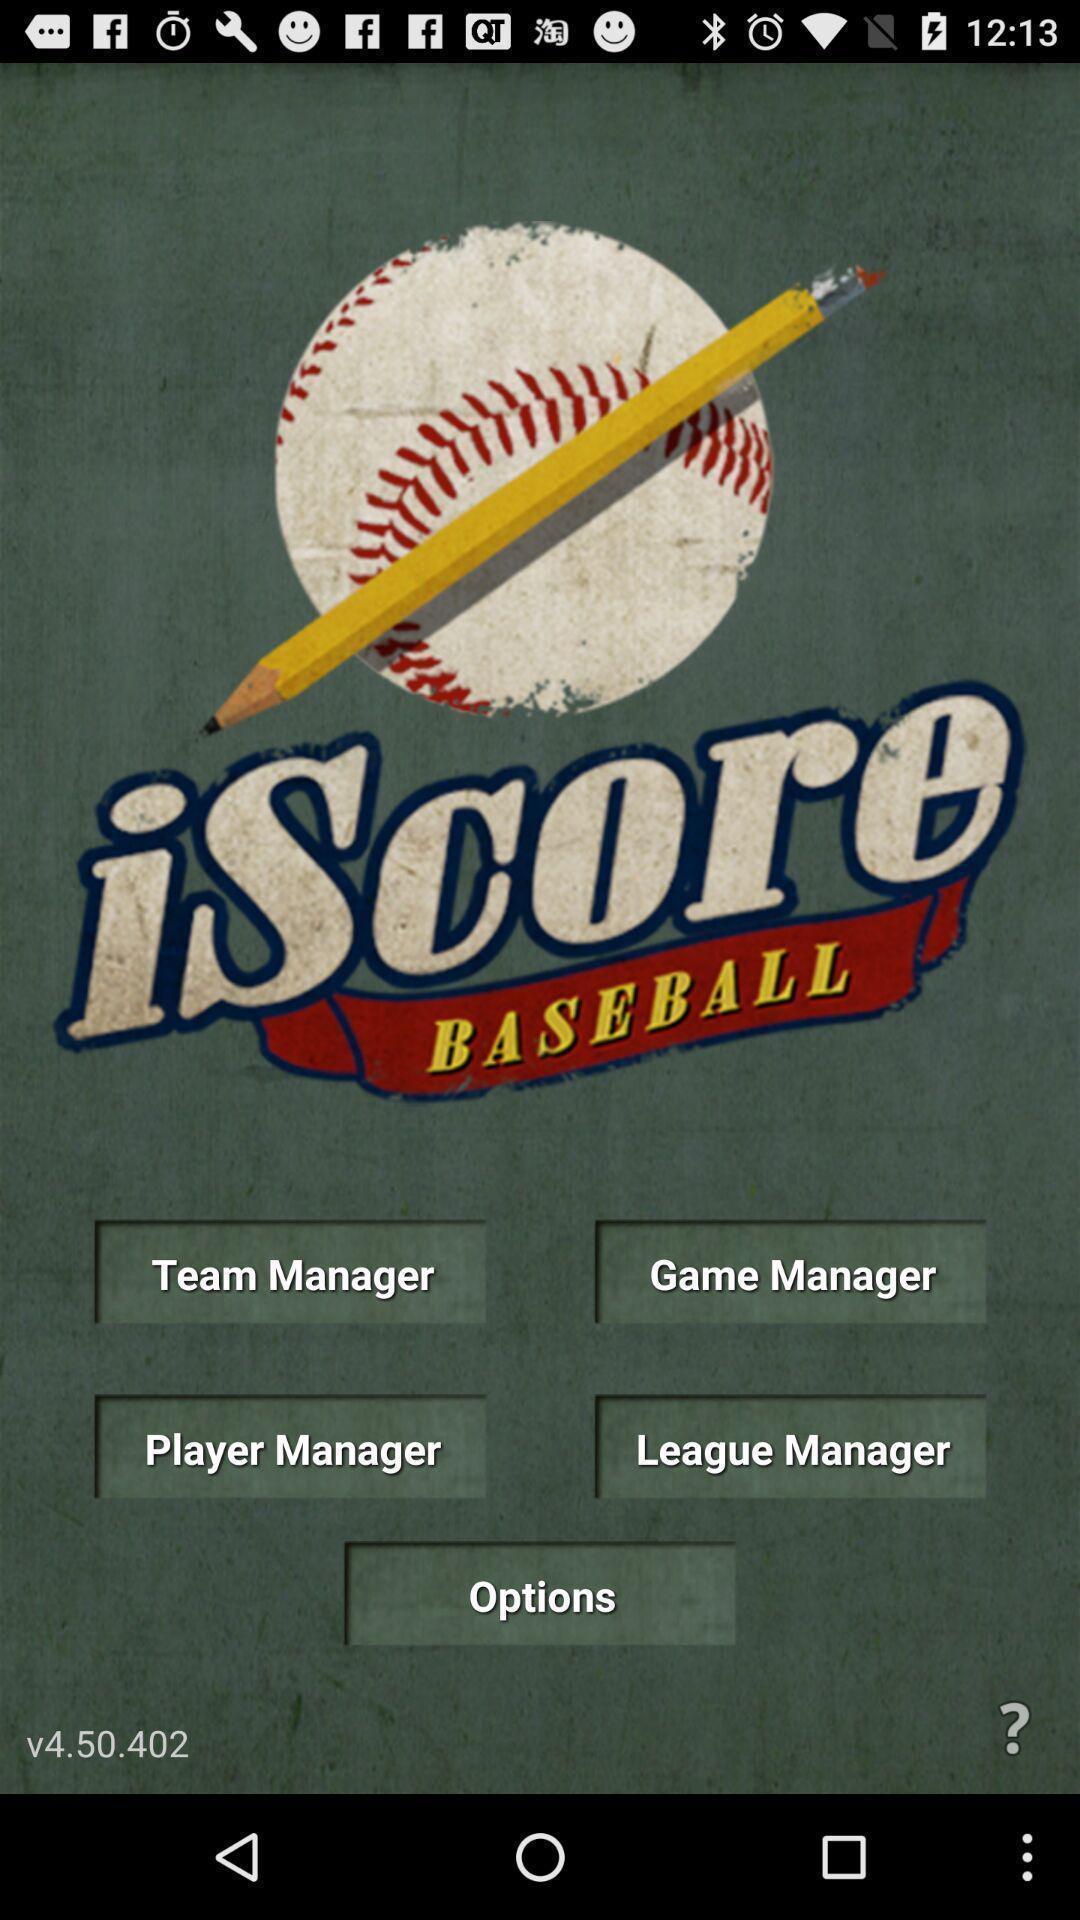Please provide a description for this image. Welcome page with different options. 